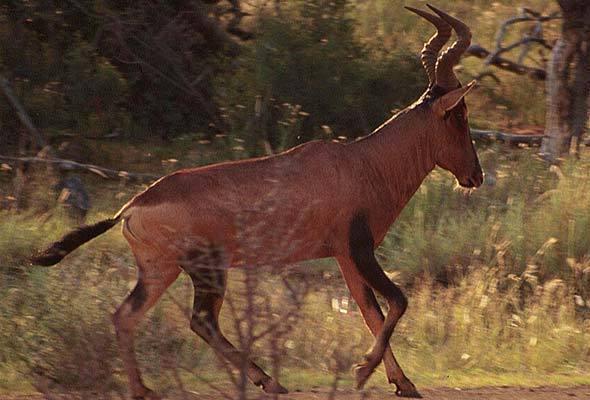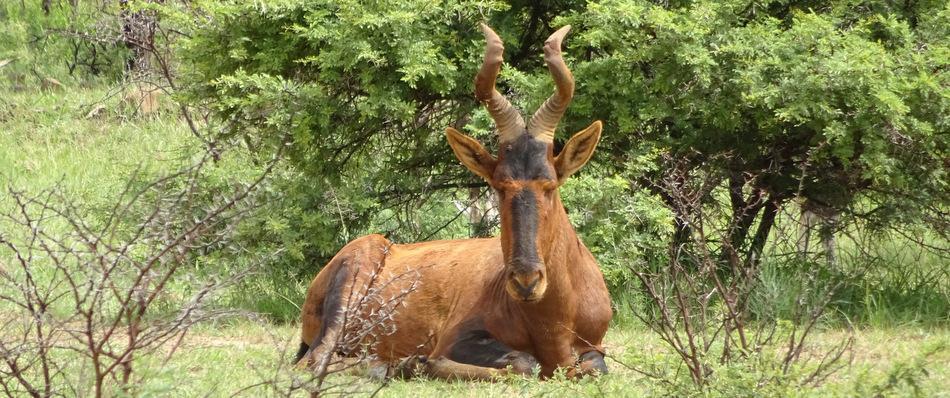The first image is the image on the left, the second image is the image on the right. Considering the images on both sides, is "In one image, none of the horned animals are standing on the ground." valid? Answer yes or no. Yes. The first image is the image on the left, the second image is the image on the right. Evaluate the accuracy of this statement regarding the images: "At least one photo has two or fewer animals.". Is it true? Answer yes or no. Yes. The first image is the image on the left, the second image is the image on the right. Evaluate the accuracy of this statement regarding the images: "The left image shows brown antelope with another type of hooved mammal.". Is it true? Answer yes or no. No. 